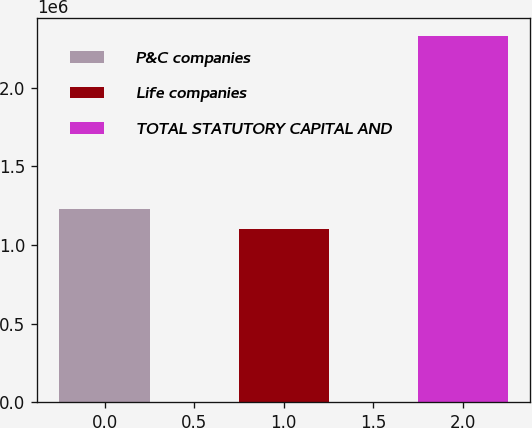Convert chart to OTSL. <chart><loc_0><loc_0><loc_500><loc_500><bar_chart><fcel>P&C companies<fcel>Life companies<fcel>TOTAL STATUTORY CAPITAL AND<nl><fcel>1.22778e+06<fcel>1.1005e+06<fcel>2.32828e+06<nl></chart> 